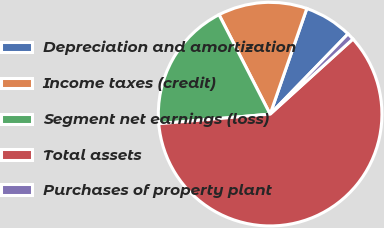Convert chart. <chart><loc_0><loc_0><loc_500><loc_500><pie_chart><fcel>Depreciation and amortization<fcel>Income taxes (credit)<fcel>Segment net earnings (loss)<fcel>Total assets<fcel>Purchases of property plant<nl><fcel>6.94%<fcel>12.88%<fcel>18.81%<fcel>60.36%<fcel>1.01%<nl></chart> 